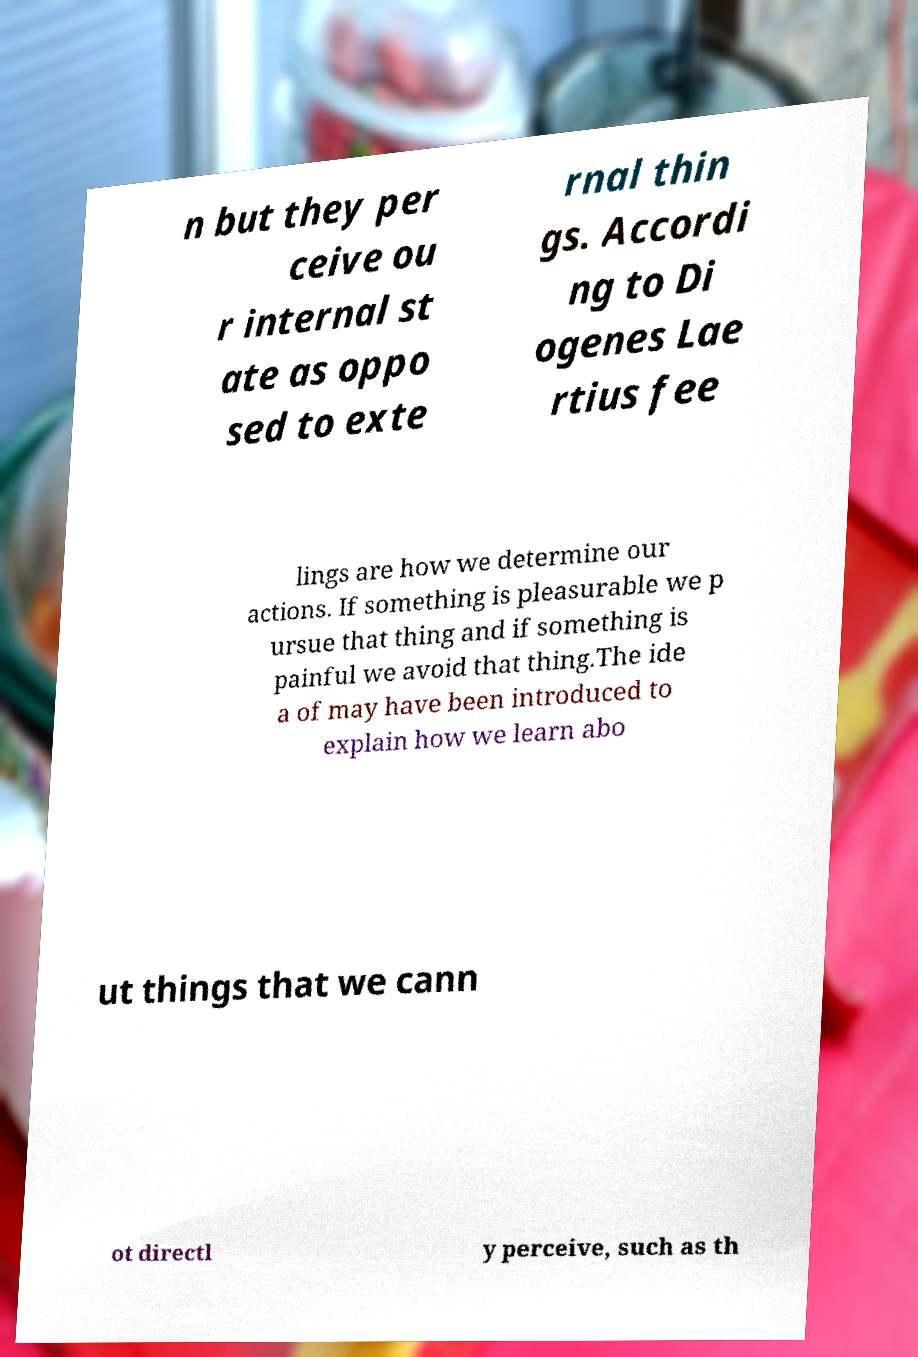What messages or text are displayed in this image? I need them in a readable, typed format. n but they per ceive ou r internal st ate as oppo sed to exte rnal thin gs. Accordi ng to Di ogenes Lae rtius fee lings are how we determine our actions. If something is pleasurable we p ursue that thing and if something is painful we avoid that thing.The ide a of may have been introduced to explain how we learn abo ut things that we cann ot directl y perceive, such as th 